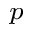<formula> <loc_0><loc_0><loc_500><loc_500>_ { p }</formula> 